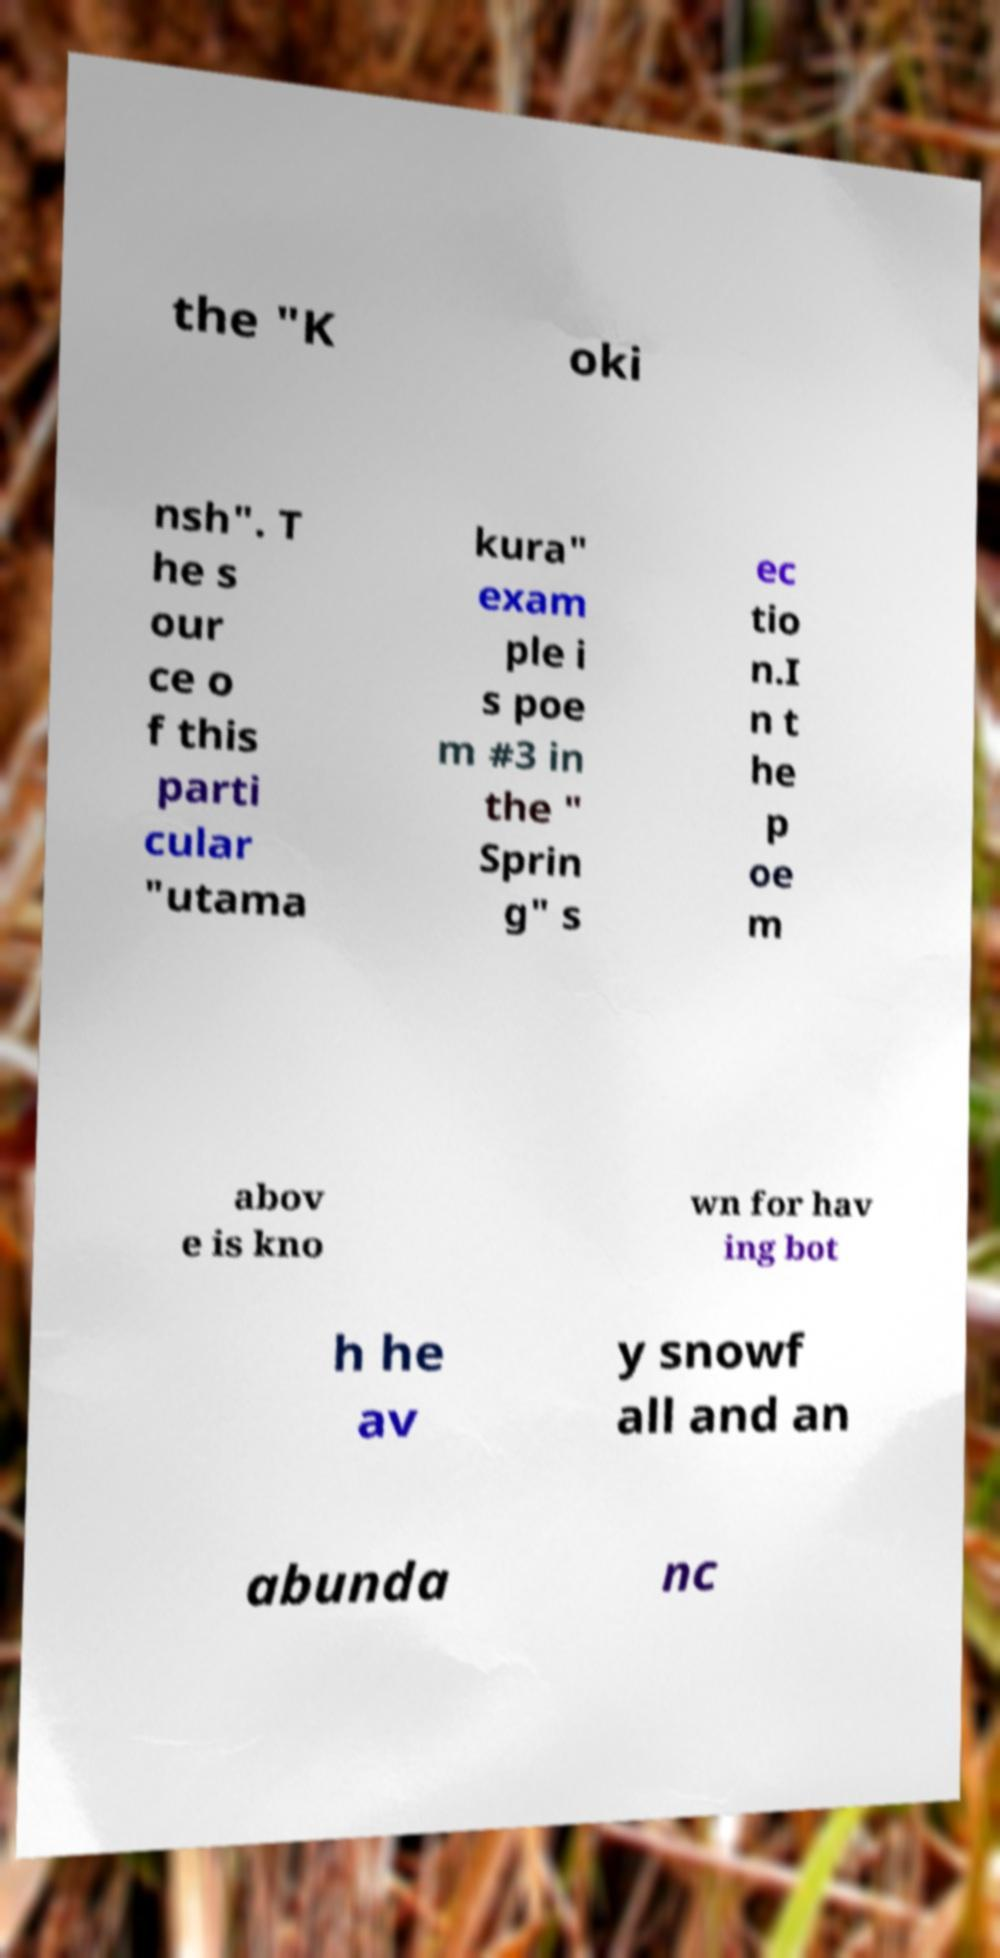Can you accurately transcribe the text from the provided image for me? the "K oki nsh". T he s our ce o f this parti cular "utama kura" exam ple i s poe m #3 in the " Sprin g" s ec tio n.I n t he p oe m abov e is kno wn for hav ing bot h he av y snowf all and an abunda nc 